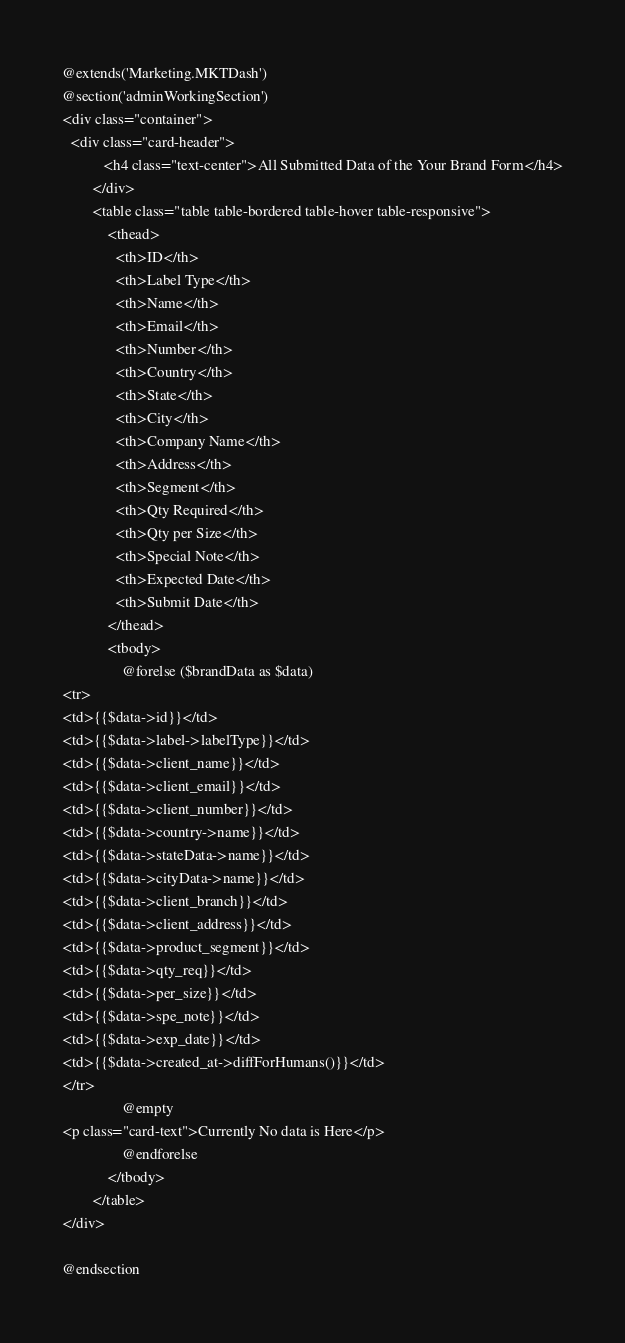Convert code to text. <code><loc_0><loc_0><loc_500><loc_500><_PHP_>@extends('Marketing.MKTDash')
@section('adminWorkingSection')
<div class="container">
  <div class="card-header">
           <h4 class="text-center">All Submitted Data of the Your Brand Form</h4>
        </div>
        <table class="table table-bordered table-hover table-responsive">
            <thead>
              <th>ID</th>
              <th>Label Type</th>
              <th>Name</th>
              <th>Email</th>
              <th>Number</th>
              <th>Country</th>
              <th>State</th>
              <th>City</th>
              <th>Company Name</th>
              <th>Address</th>
              <th>Segment</th>
              <th>Qty Required</th>
              <th>Qty per Size</th>
              <th>Special Note</th>
              <th>Expected Date</th>
              <th>Submit Date</th>
            </thead>
            <tbody>
                @forelse ($brandData as $data)
<tr>
<td>{{$data->id}}</td>
<td>{{$data->label->labelType}}</td>
<td>{{$data->client_name}}</td>
<td>{{$data->client_email}}</td>
<td>{{$data->client_number}}</td>
<td>{{$data->country->name}}</td>
<td>{{$data->stateData->name}}</td>
<td>{{$data->cityData->name}}</td>
<td>{{$data->client_branch}}</td>
<td>{{$data->client_address}}</td>
<td>{{$data->product_segment}}</td>
<td>{{$data->qty_req}}</td>
<td>{{$data->per_size}}</td>
<td>{{$data->spe_note}}</td>
<td>{{$data->exp_date}}</td>
<td>{{$data->created_at->diffForHumans()}}</td>
</tr>
                @empty
<p class="card-text">Currently No data is Here</p>
                @endforelse
            </tbody>
        </table>
</div>

@endsection
</code> 